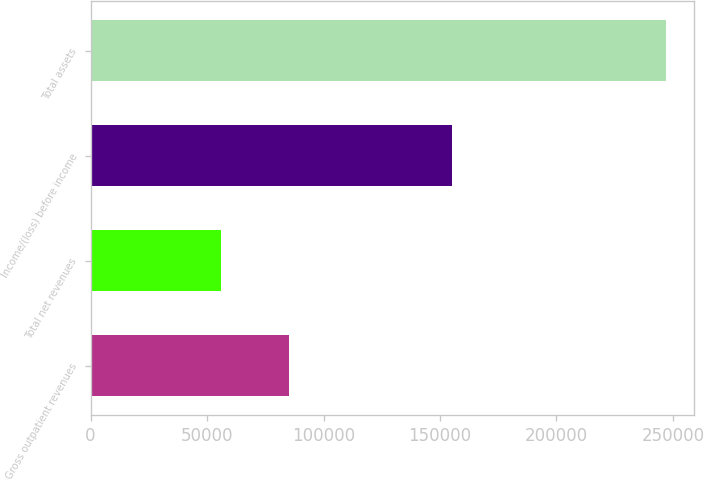Convert chart. <chart><loc_0><loc_0><loc_500><loc_500><bar_chart><fcel>Gross outpatient revenues<fcel>Total net revenues<fcel>Income/(loss) before income<fcel>Total assets<nl><fcel>85294<fcel>55950<fcel>155129<fcel>246867<nl></chart> 